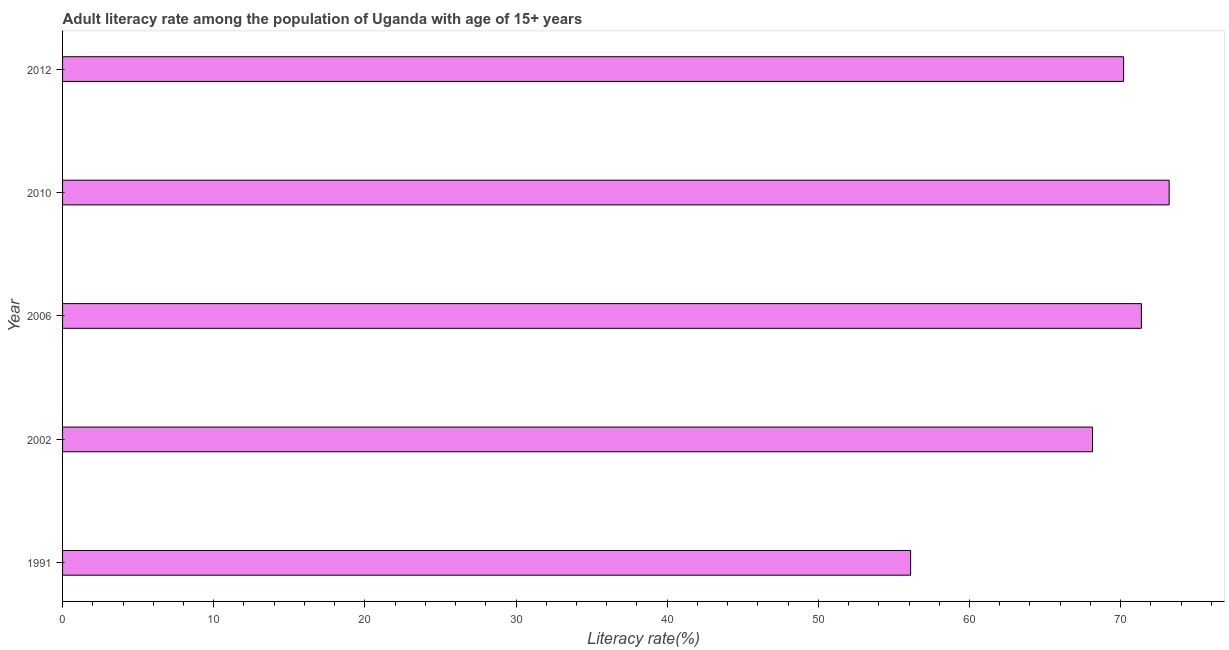What is the title of the graph?
Offer a terse response. Adult literacy rate among the population of Uganda with age of 15+ years. What is the label or title of the X-axis?
Your response must be concise. Literacy rate(%). What is the label or title of the Y-axis?
Ensure brevity in your answer.  Year. What is the adult literacy rate in 1991?
Make the answer very short. 56.11. Across all years, what is the maximum adult literacy rate?
Give a very brief answer. 73.21. Across all years, what is the minimum adult literacy rate?
Provide a succinct answer. 56.11. In which year was the adult literacy rate maximum?
Provide a short and direct response. 2010. In which year was the adult literacy rate minimum?
Your response must be concise. 1991. What is the sum of the adult literacy rate?
Offer a very short reply. 339.03. What is the difference between the adult literacy rate in 2002 and 2012?
Make the answer very short. -2.06. What is the average adult literacy rate per year?
Provide a succinct answer. 67.81. What is the median adult literacy rate?
Provide a succinct answer. 70.2. In how many years, is the adult literacy rate greater than 66 %?
Give a very brief answer. 4. Do a majority of the years between 2002 and 2012 (inclusive) have adult literacy rate greater than 48 %?
Keep it short and to the point. Yes. What is the ratio of the adult literacy rate in 2002 to that in 2010?
Offer a very short reply. 0.93. What is the difference between the highest and the second highest adult literacy rate?
Your response must be concise. 1.84. How many bars are there?
Your answer should be very brief. 5. How many years are there in the graph?
Provide a short and direct response. 5. Are the values on the major ticks of X-axis written in scientific E-notation?
Provide a short and direct response. No. What is the Literacy rate(%) in 1991?
Your response must be concise. 56.11. What is the Literacy rate(%) in 2002?
Offer a very short reply. 68.14. What is the Literacy rate(%) in 2006?
Offer a very short reply. 71.37. What is the Literacy rate(%) of 2010?
Keep it short and to the point. 73.21. What is the Literacy rate(%) in 2012?
Provide a short and direct response. 70.2. What is the difference between the Literacy rate(%) in 1991 and 2002?
Provide a short and direct response. -12.04. What is the difference between the Literacy rate(%) in 1991 and 2006?
Your response must be concise. -15.27. What is the difference between the Literacy rate(%) in 1991 and 2010?
Offer a very short reply. -17.1. What is the difference between the Literacy rate(%) in 1991 and 2012?
Ensure brevity in your answer.  -14.09. What is the difference between the Literacy rate(%) in 2002 and 2006?
Offer a very short reply. -3.23. What is the difference between the Literacy rate(%) in 2002 and 2010?
Ensure brevity in your answer.  -5.07. What is the difference between the Literacy rate(%) in 2002 and 2012?
Your answer should be very brief. -2.06. What is the difference between the Literacy rate(%) in 2006 and 2010?
Provide a short and direct response. -1.84. What is the difference between the Literacy rate(%) in 2006 and 2012?
Provide a succinct answer. 1.17. What is the difference between the Literacy rate(%) in 2010 and 2012?
Your answer should be compact. 3.01. What is the ratio of the Literacy rate(%) in 1991 to that in 2002?
Your answer should be compact. 0.82. What is the ratio of the Literacy rate(%) in 1991 to that in 2006?
Your answer should be compact. 0.79. What is the ratio of the Literacy rate(%) in 1991 to that in 2010?
Make the answer very short. 0.77. What is the ratio of the Literacy rate(%) in 1991 to that in 2012?
Give a very brief answer. 0.8. What is the ratio of the Literacy rate(%) in 2002 to that in 2006?
Offer a very short reply. 0.95. What is the ratio of the Literacy rate(%) in 2006 to that in 2010?
Your answer should be very brief. 0.97. What is the ratio of the Literacy rate(%) in 2006 to that in 2012?
Provide a succinct answer. 1.02. What is the ratio of the Literacy rate(%) in 2010 to that in 2012?
Offer a terse response. 1.04. 